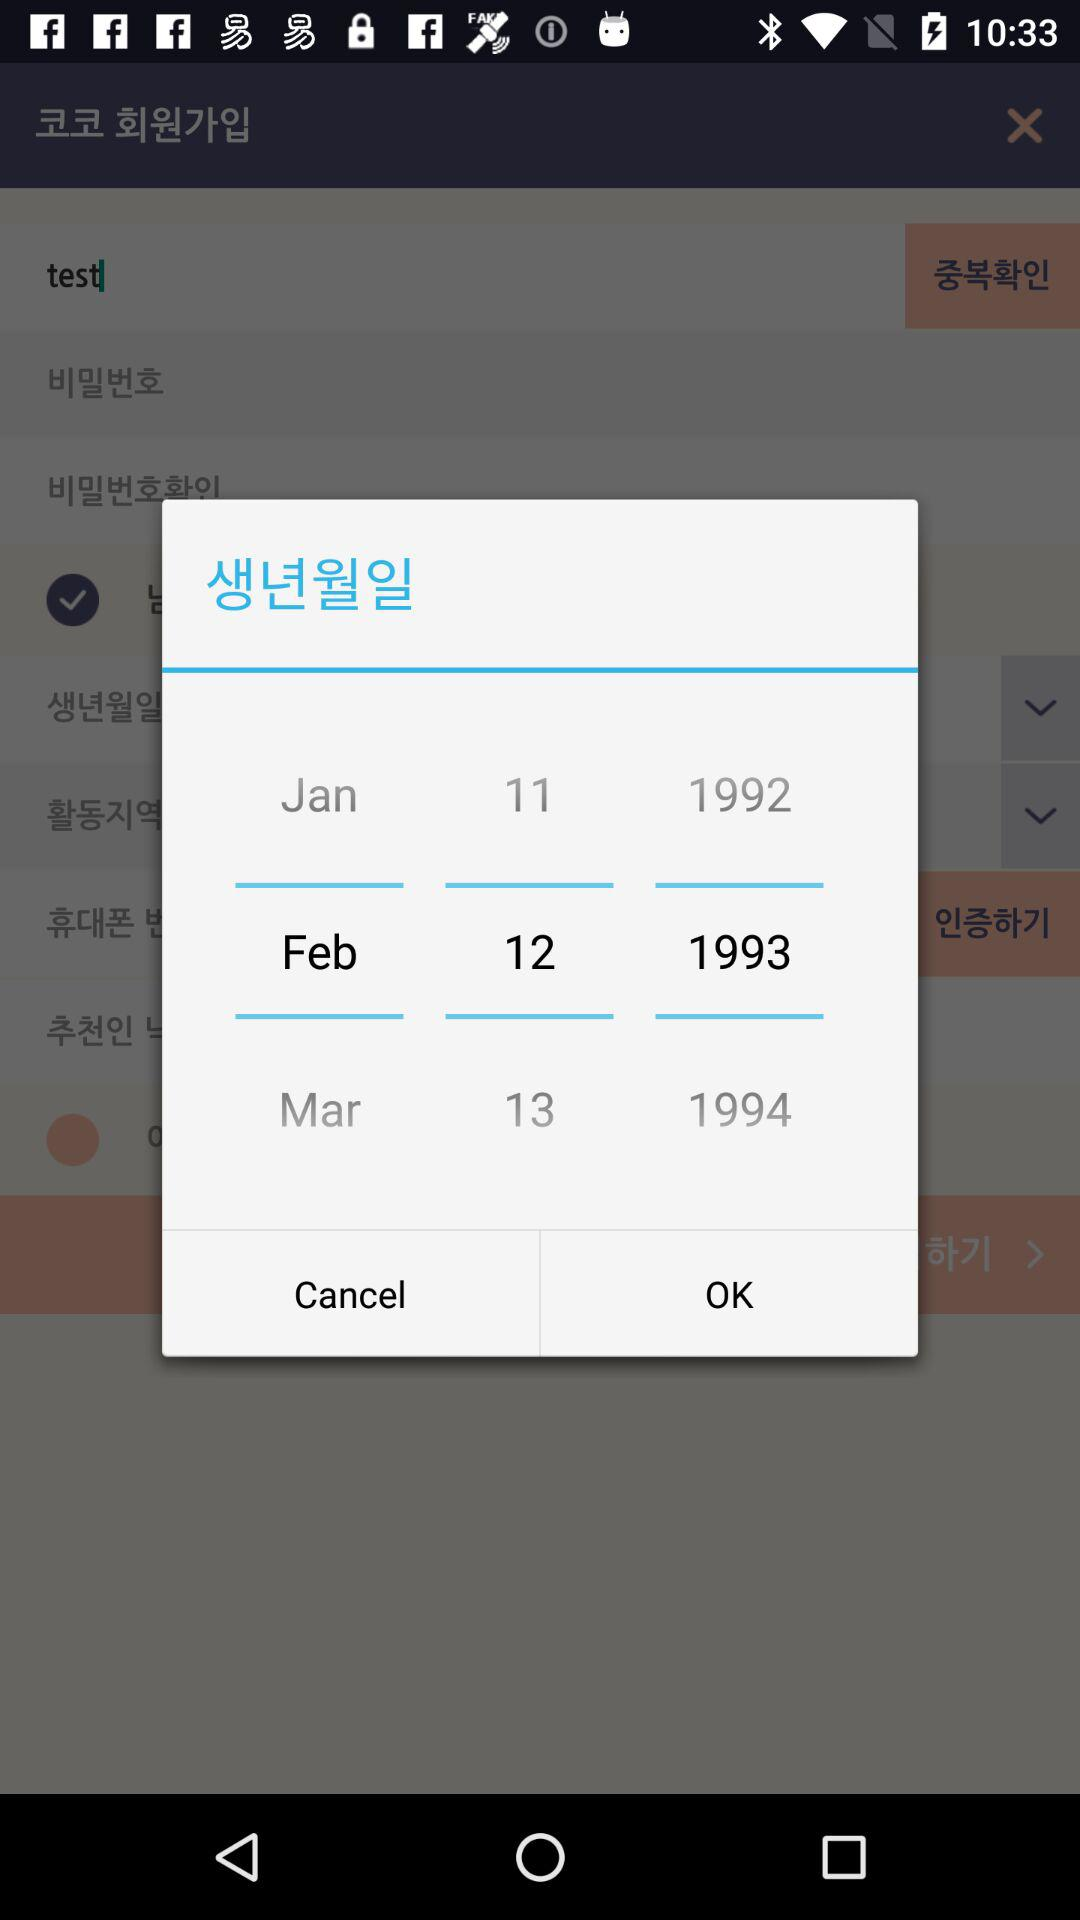What is the selected date? The selected date is February 12, 1993. 